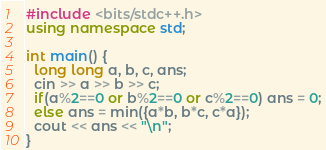Convert code to text. <code><loc_0><loc_0><loc_500><loc_500><_C++_>#include <bits/stdc++.h>
using namespace std;

int main() {
  long long a, b, c, ans;
  cin >> a >> b >> c;
  if(a%2==0 or b%2==0 or c%2==0) ans = 0;
  else ans = min({a*b, b*c, c*a});
  cout << ans << "\n";
}</code> 